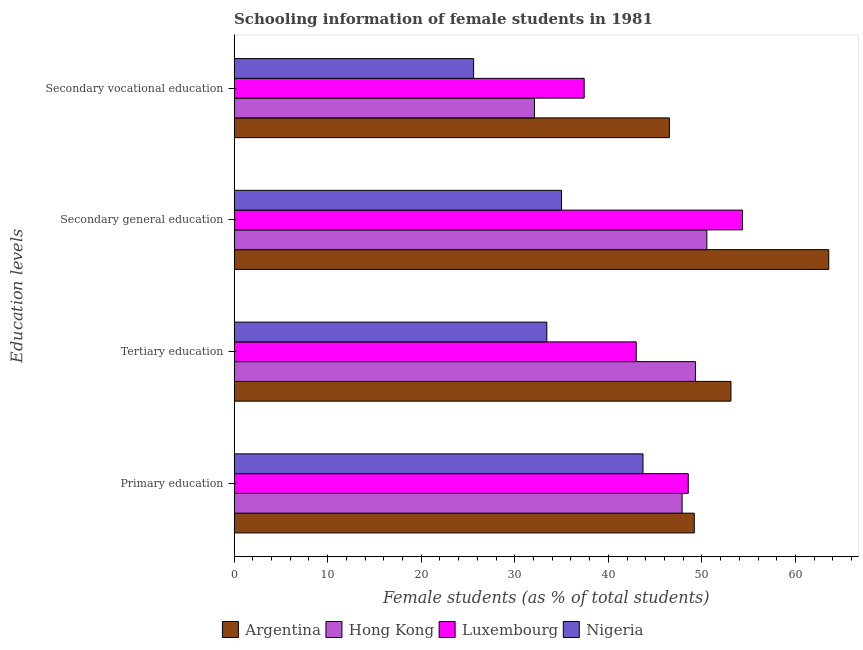How many different coloured bars are there?
Your answer should be very brief. 4. How many groups of bars are there?
Your answer should be very brief. 4. Are the number of bars per tick equal to the number of legend labels?
Make the answer very short. Yes. How many bars are there on the 4th tick from the top?
Provide a succinct answer. 4. How many bars are there on the 2nd tick from the bottom?
Make the answer very short. 4. What is the label of the 2nd group of bars from the top?
Keep it short and to the point. Secondary general education. What is the percentage of female students in secondary education in Argentina?
Your response must be concise. 63.55. Across all countries, what is the maximum percentage of female students in primary education?
Provide a succinct answer. 49.18. Across all countries, what is the minimum percentage of female students in tertiary education?
Ensure brevity in your answer.  33.42. In which country was the percentage of female students in secondary vocational education maximum?
Provide a succinct answer. Argentina. In which country was the percentage of female students in secondary vocational education minimum?
Give a very brief answer. Nigeria. What is the total percentage of female students in secondary vocational education in the graph?
Your answer should be compact. 141.63. What is the difference between the percentage of female students in tertiary education in Argentina and that in Nigeria?
Provide a short and direct response. 19.68. What is the difference between the percentage of female students in secondary vocational education in Hong Kong and the percentage of female students in secondary education in Nigeria?
Offer a very short reply. -2.89. What is the average percentage of female students in tertiary education per country?
Offer a very short reply. 44.7. What is the difference between the percentage of female students in primary education and percentage of female students in secondary education in Hong Kong?
Your answer should be compact. -2.64. In how many countries, is the percentage of female students in secondary education greater than 50 %?
Offer a very short reply. 3. What is the ratio of the percentage of female students in secondary education in Nigeria to that in Luxembourg?
Give a very brief answer. 0.64. Is the difference between the percentage of female students in primary education in Hong Kong and Argentina greater than the difference between the percentage of female students in secondary education in Hong Kong and Argentina?
Your answer should be compact. Yes. What is the difference between the highest and the second highest percentage of female students in secondary education?
Give a very brief answer. 9.22. What is the difference between the highest and the lowest percentage of female students in tertiary education?
Your answer should be very brief. 19.68. In how many countries, is the percentage of female students in tertiary education greater than the average percentage of female students in tertiary education taken over all countries?
Your answer should be compact. 2. Is the sum of the percentage of female students in primary education in Hong Kong and Nigeria greater than the maximum percentage of female students in tertiary education across all countries?
Keep it short and to the point. Yes. Is it the case that in every country, the sum of the percentage of female students in primary education and percentage of female students in secondary vocational education is greater than the sum of percentage of female students in secondary education and percentage of female students in tertiary education?
Offer a very short reply. No. What does the 2nd bar from the top in Tertiary education represents?
Ensure brevity in your answer.  Luxembourg. What does the 3rd bar from the bottom in Secondary vocational education represents?
Ensure brevity in your answer.  Luxembourg. Is it the case that in every country, the sum of the percentage of female students in primary education and percentage of female students in tertiary education is greater than the percentage of female students in secondary education?
Ensure brevity in your answer.  Yes. Are all the bars in the graph horizontal?
Offer a terse response. Yes. What is the difference between two consecutive major ticks on the X-axis?
Offer a very short reply. 10. Are the values on the major ticks of X-axis written in scientific E-notation?
Provide a short and direct response. No. Does the graph contain grids?
Your response must be concise. No. How are the legend labels stacked?
Provide a succinct answer. Horizontal. What is the title of the graph?
Offer a terse response. Schooling information of female students in 1981. Does "Puerto Rico" appear as one of the legend labels in the graph?
Your response must be concise. No. What is the label or title of the X-axis?
Your response must be concise. Female students (as % of total students). What is the label or title of the Y-axis?
Your answer should be compact. Education levels. What is the Female students (as % of total students) of Argentina in Primary education?
Make the answer very short. 49.18. What is the Female students (as % of total students) of Hong Kong in Primary education?
Provide a succinct answer. 47.88. What is the Female students (as % of total students) of Luxembourg in Primary education?
Your answer should be very brief. 48.54. What is the Female students (as % of total students) in Nigeria in Primary education?
Your answer should be compact. 43.7. What is the Female students (as % of total students) in Argentina in Tertiary education?
Make the answer very short. 53.1. What is the Female students (as % of total students) in Hong Kong in Tertiary education?
Keep it short and to the point. 49.31. What is the Female students (as % of total students) of Luxembourg in Tertiary education?
Your answer should be compact. 42.98. What is the Female students (as % of total students) in Nigeria in Tertiary education?
Your answer should be compact. 33.42. What is the Female students (as % of total students) of Argentina in Secondary general education?
Keep it short and to the point. 63.55. What is the Female students (as % of total students) of Hong Kong in Secondary general education?
Offer a very short reply. 50.53. What is the Female students (as % of total students) in Luxembourg in Secondary general education?
Keep it short and to the point. 54.33. What is the Female students (as % of total students) of Nigeria in Secondary general education?
Give a very brief answer. 34.99. What is the Female students (as % of total students) in Argentina in Secondary vocational education?
Make the answer very short. 46.52. What is the Female students (as % of total students) of Hong Kong in Secondary vocational education?
Your answer should be compact. 32.1. What is the Female students (as % of total students) of Luxembourg in Secondary vocational education?
Provide a short and direct response. 37.41. What is the Female students (as % of total students) in Nigeria in Secondary vocational education?
Give a very brief answer. 25.59. Across all Education levels, what is the maximum Female students (as % of total students) in Argentina?
Your answer should be very brief. 63.55. Across all Education levels, what is the maximum Female students (as % of total students) in Hong Kong?
Ensure brevity in your answer.  50.53. Across all Education levels, what is the maximum Female students (as % of total students) in Luxembourg?
Make the answer very short. 54.33. Across all Education levels, what is the maximum Female students (as % of total students) of Nigeria?
Make the answer very short. 43.7. Across all Education levels, what is the minimum Female students (as % of total students) in Argentina?
Keep it short and to the point. 46.52. Across all Education levels, what is the minimum Female students (as % of total students) of Hong Kong?
Make the answer very short. 32.1. Across all Education levels, what is the minimum Female students (as % of total students) of Luxembourg?
Your answer should be compact. 37.41. Across all Education levels, what is the minimum Female students (as % of total students) in Nigeria?
Give a very brief answer. 25.59. What is the total Female students (as % of total students) of Argentina in the graph?
Offer a terse response. 212.36. What is the total Female students (as % of total students) of Hong Kong in the graph?
Keep it short and to the point. 179.82. What is the total Female students (as % of total students) of Luxembourg in the graph?
Offer a very short reply. 183.26. What is the total Female students (as % of total students) in Nigeria in the graph?
Your answer should be compact. 137.71. What is the difference between the Female students (as % of total students) of Argentina in Primary education and that in Tertiary education?
Provide a short and direct response. -3.92. What is the difference between the Female students (as % of total students) of Hong Kong in Primary education and that in Tertiary education?
Your answer should be compact. -1.43. What is the difference between the Female students (as % of total students) in Luxembourg in Primary education and that in Tertiary education?
Your answer should be very brief. 5.56. What is the difference between the Female students (as % of total students) in Nigeria in Primary education and that in Tertiary education?
Offer a very short reply. 10.28. What is the difference between the Female students (as % of total students) in Argentina in Primary education and that in Secondary general education?
Offer a terse response. -14.37. What is the difference between the Female students (as % of total students) in Hong Kong in Primary education and that in Secondary general education?
Your answer should be very brief. -2.64. What is the difference between the Female students (as % of total students) in Luxembourg in Primary education and that in Secondary general education?
Offer a very short reply. -5.79. What is the difference between the Female students (as % of total students) in Nigeria in Primary education and that in Secondary general education?
Ensure brevity in your answer.  8.71. What is the difference between the Female students (as % of total students) in Argentina in Primary education and that in Secondary vocational education?
Provide a short and direct response. 2.66. What is the difference between the Female students (as % of total students) of Hong Kong in Primary education and that in Secondary vocational education?
Ensure brevity in your answer.  15.78. What is the difference between the Female students (as % of total students) of Luxembourg in Primary education and that in Secondary vocational education?
Provide a short and direct response. 11.12. What is the difference between the Female students (as % of total students) of Nigeria in Primary education and that in Secondary vocational education?
Offer a very short reply. 18.11. What is the difference between the Female students (as % of total students) in Argentina in Tertiary education and that in Secondary general education?
Give a very brief answer. -10.45. What is the difference between the Female students (as % of total students) in Hong Kong in Tertiary education and that in Secondary general education?
Provide a short and direct response. -1.22. What is the difference between the Female students (as % of total students) of Luxembourg in Tertiary education and that in Secondary general education?
Provide a short and direct response. -11.36. What is the difference between the Female students (as % of total students) of Nigeria in Tertiary education and that in Secondary general education?
Your answer should be very brief. -1.57. What is the difference between the Female students (as % of total students) in Argentina in Tertiary education and that in Secondary vocational education?
Keep it short and to the point. 6.58. What is the difference between the Female students (as % of total students) in Hong Kong in Tertiary education and that in Secondary vocational education?
Your answer should be compact. 17.2. What is the difference between the Female students (as % of total students) in Luxembourg in Tertiary education and that in Secondary vocational education?
Offer a very short reply. 5.56. What is the difference between the Female students (as % of total students) of Nigeria in Tertiary education and that in Secondary vocational education?
Your response must be concise. 7.83. What is the difference between the Female students (as % of total students) in Argentina in Secondary general education and that in Secondary vocational education?
Provide a succinct answer. 17.04. What is the difference between the Female students (as % of total students) of Hong Kong in Secondary general education and that in Secondary vocational education?
Keep it short and to the point. 18.42. What is the difference between the Female students (as % of total students) of Luxembourg in Secondary general education and that in Secondary vocational education?
Your response must be concise. 16.92. What is the difference between the Female students (as % of total students) of Nigeria in Secondary general education and that in Secondary vocational education?
Provide a succinct answer. 9.4. What is the difference between the Female students (as % of total students) of Argentina in Primary education and the Female students (as % of total students) of Hong Kong in Tertiary education?
Provide a short and direct response. -0.13. What is the difference between the Female students (as % of total students) in Argentina in Primary education and the Female students (as % of total students) in Luxembourg in Tertiary education?
Keep it short and to the point. 6.2. What is the difference between the Female students (as % of total students) in Argentina in Primary education and the Female students (as % of total students) in Nigeria in Tertiary education?
Provide a succinct answer. 15.76. What is the difference between the Female students (as % of total students) of Hong Kong in Primary education and the Female students (as % of total students) of Luxembourg in Tertiary education?
Your answer should be compact. 4.9. What is the difference between the Female students (as % of total students) of Hong Kong in Primary education and the Female students (as % of total students) of Nigeria in Tertiary education?
Offer a terse response. 14.46. What is the difference between the Female students (as % of total students) in Luxembourg in Primary education and the Female students (as % of total students) in Nigeria in Tertiary education?
Your answer should be compact. 15.11. What is the difference between the Female students (as % of total students) in Argentina in Primary education and the Female students (as % of total students) in Hong Kong in Secondary general education?
Provide a succinct answer. -1.34. What is the difference between the Female students (as % of total students) of Argentina in Primary education and the Female students (as % of total students) of Luxembourg in Secondary general education?
Offer a very short reply. -5.15. What is the difference between the Female students (as % of total students) of Argentina in Primary education and the Female students (as % of total students) of Nigeria in Secondary general education?
Provide a succinct answer. 14.19. What is the difference between the Female students (as % of total students) in Hong Kong in Primary education and the Female students (as % of total students) in Luxembourg in Secondary general education?
Provide a short and direct response. -6.45. What is the difference between the Female students (as % of total students) of Hong Kong in Primary education and the Female students (as % of total students) of Nigeria in Secondary general education?
Give a very brief answer. 12.89. What is the difference between the Female students (as % of total students) of Luxembourg in Primary education and the Female students (as % of total students) of Nigeria in Secondary general education?
Provide a short and direct response. 13.55. What is the difference between the Female students (as % of total students) in Argentina in Primary education and the Female students (as % of total students) in Hong Kong in Secondary vocational education?
Offer a very short reply. 17.08. What is the difference between the Female students (as % of total students) in Argentina in Primary education and the Female students (as % of total students) in Luxembourg in Secondary vocational education?
Your answer should be compact. 11.77. What is the difference between the Female students (as % of total students) of Argentina in Primary education and the Female students (as % of total students) of Nigeria in Secondary vocational education?
Your answer should be very brief. 23.59. What is the difference between the Female students (as % of total students) of Hong Kong in Primary education and the Female students (as % of total students) of Luxembourg in Secondary vocational education?
Provide a succinct answer. 10.47. What is the difference between the Female students (as % of total students) of Hong Kong in Primary education and the Female students (as % of total students) of Nigeria in Secondary vocational education?
Keep it short and to the point. 22.29. What is the difference between the Female students (as % of total students) of Luxembourg in Primary education and the Female students (as % of total students) of Nigeria in Secondary vocational education?
Your response must be concise. 22.94. What is the difference between the Female students (as % of total students) in Argentina in Tertiary education and the Female students (as % of total students) in Hong Kong in Secondary general education?
Give a very brief answer. 2.58. What is the difference between the Female students (as % of total students) of Argentina in Tertiary education and the Female students (as % of total students) of Luxembourg in Secondary general education?
Your answer should be compact. -1.23. What is the difference between the Female students (as % of total students) in Argentina in Tertiary education and the Female students (as % of total students) in Nigeria in Secondary general education?
Keep it short and to the point. 18.11. What is the difference between the Female students (as % of total students) of Hong Kong in Tertiary education and the Female students (as % of total students) of Luxembourg in Secondary general education?
Keep it short and to the point. -5.03. What is the difference between the Female students (as % of total students) in Hong Kong in Tertiary education and the Female students (as % of total students) in Nigeria in Secondary general education?
Ensure brevity in your answer.  14.31. What is the difference between the Female students (as % of total students) of Luxembourg in Tertiary education and the Female students (as % of total students) of Nigeria in Secondary general education?
Your answer should be very brief. 7.98. What is the difference between the Female students (as % of total students) of Argentina in Tertiary education and the Female students (as % of total students) of Hong Kong in Secondary vocational education?
Provide a short and direct response. 21. What is the difference between the Female students (as % of total students) of Argentina in Tertiary education and the Female students (as % of total students) of Luxembourg in Secondary vocational education?
Provide a short and direct response. 15.69. What is the difference between the Female students (as % of total students) of Argentina in Tertiary education and the Female students (as % of total students) of Nigeria in Secondary vocational education?
Provide a succinct answer. 27.51. What is the difference between the Female students (as % of total students) in Hong Kong in Tertiary education and the Female students (as % of total students) in Luxembourg in Secondary vocational education?
Your response must be concise. 11.89. What is the difference between the Female students (as % of total students) in Hong Kong in Tertiary education and the Female students (as % of total students) in Nigeria in Secondary vocational education?
Your response must be concise. 23.71. What is the difference between the Female students (as % of total students) of Luxembourg in Tertiary education and the Female students (as % of total students) of Nigeria in Secondary vocational education?
Make the answer very short. 17.38. What is the difference between the Female students (as % of total students) in Argentina in Secondary general education and the Female students (as % of total students) in Hong Kong in Secondary vocational education?
Provide a succinct answer. 31.45. What is the difference between the Female students (as % of total students) in Argentina in Secondary general education and the Female students (as % of total students) in Luxembourg in Secondary vocational education?
Offer a very short reply. 26.14. What is the difference between the Female students (as % of total students) of Argentina in Secondary general education and the Female students (as % of total students) of Nigeria in Secondary vocational education?
Your response must be concise. 37.96. What is the difference between the Female students (as % of total students) of Hong Kong in Secondary general education and the Female students (as % of total students) of Luxembourg in Secondary vocational education?
Give a very brief answer. 13.11. What is the difference between the Female students (as % of total students) of Hong Kong in Secondary general education and the Female students (as % of total students) of Nigeria in Secondary vocational education?
Make the answer very short. 24.93. What is the difference between the Female students (as % of total students) of Luxembourg in Secondary general education and the Female students (as % of total students) of Nigeria in Secondary vocational education?
Give a very brief answer. 28.74. What is the average Female students (as % of total students) of Argentina per Education levels?
Offer a very short reply. 53.09. What is the average Female students (as % of total students) of Hong Kong per Education levels?
Your answer should be compact. 44.95. What is the average Female students (as % of total students) of Luxembourg per Education levels?
Your answer should be compact. 45.82. What is the average Female students (as % of total students) of Nigeria per Education levels?
Make the answer very short. 34.43. What is the difference between the Female students (as % of total students) of Argentina and Female students (as % of total students) of Hong Kong in Primary education?
Your answer should be very brief. 1.3. What is the difference between the Female students (as % of total students) in Argentina and Female students (as % of total students) in Luxembourg in Primary education?
Your answer should be very brief. 0.64. What is the difference between the Female students (as % of total students) in Argentina and Female students (as % of total students) in Nigeria in Primary education?
Offer a very short reply. 5.48. What is the difference between the Female students (as % of total students) of Hong Kong and Female students (as % of total students) of Luxembourg in Primary education?
Ensure brevity in your answer.  -0.66. What is the difference between the Female students (as % of total students) in Hong Kong and Female students (as % of total students) in Nigeria in Primary education?
Give a very brief answer. 4.18. What is the difference between the Female students (as % of total students) of Luxembourg and Female students (as % of total students) of Nigeria in Primary education?
Your response must be concise. 4.84. What is the difference between the Female students (as % of total students) of Argentina and Female students (as % of total students) of Hong Kong in Tertiary education?
Your answer should be compact. 3.8. What is the difference between the Female students (as % of total students) in Argentina and Female students (as % of total students) in Luxembourg in Tertiary education?
Keep it short and to the point. 10.13. What is the difference between the Female students (as % of total students) of Argentina and Female students (as % of total students) of Nigeria in Tertiary education?
Your answer should be very brief. 19.68. What is the difference between the Female students (as % of total students) in Hong Kong and Female students (as % of total students) in Luxembourg in Tertiary education?
Your response must be concise. 6.33. What is the difference between the Female students (as % of total students) in Hong Kong and Female students (as % of total students) in Nigeria in Tertiary education?
Offer a terse response. 15.88. What is the difference between the Female students (as % of total students) in Luxembourg and Female students (as % of total students) in Nigeria in Tertiary education?
Your answer should be very brief. 9.55. What is the difference between the Female students (as % of total students) in Argentina and Female students (as % of total students) in Hong Kong in Secondary general education?
Ensure brevity in your answer.  13.03. What is the difference between the Female students (as % of total students) in Argentina and Female students (as % of total students) in Luxembourg in Secondary general education?
Your response must be concise. 9.22. What is the difference between the Female students (as % of total students) in Argentina and Female students (as % of total students) in Nigeria in Secondary general education?
Your answer should be compact. 28.56. What is the difference between the Female students (as % of total students) in Hong Kong and Female students (as % of total students) in Luxembourg in Secondary general education?
Ensure brevity in your answer.  -3.81. What is the difference between the Female students (as % of total students) in Hong Kong and Female students (as % of total students) in Nigeria in Secondary general education?
Offer a terse response. 15.53. What is the difference between the Female students (as % of total students) in Luxembourg and Female students (as % of total students) in Nigeria in Secondary general education?
Ensure brevity in your answer.  19.34. What is the difference between the Female students (as % of total students) in Argentina and Female students (as % of total students) in Hong Kong in Secondary vocational education?
Keep it short and to the point. 14.42. What is the difference between the Female students (as % of total students) in Argentina and Female students (as % of total students) in Luxembourg in Secondary vocational education?
Ensure brevity in your answer.  9.1. What is the difference between the Female students (as % of total students) of Argentina and Female students (as % of total students) of Nigeria in Secondary vocational education?
Your answer should be compact. 20.92. What is the difference between the Female students (as % of total students) of Hong Kong and Female students (as % of total students) of Luxembourg in Secondary vocational education?
Provide a short and direct response. -5.31. What is the difference between the Female students (as % of total students) in Hong Kong and Female students (as % of total students) in Nigeria in Secondary vocational education?
Provide a short and direct response. 6.51. What is the difference between the Female students (as % of total students) of Luxembourg and Female students (as % of total students) of Nigeria in Secondary vocational education?
Your answer should be compact. 11.82. What is the ratio of the Female students (as % of total students) of Argentina in Primary education to that in Tertiary education?
Give a very brief answer. 0.93. What is the ratio of the Female students (as % of total students) in Hong Kong in Primary education to that in Tertiary education?
Provide a short and direct response. 0.97. What is the ratio of the Female students (as % of total students) of Luxembourg in Primary education to that in Tertiary education?
Provide a succinct answer. 1.13. What is the ratio of the Female students (as % of total students) of Nigeria in Primary education to that in Tertiary education?
Keep it short and to the point. 1.31. What is the ratio of the Female students (as % of total students) in Argentina in Primary education to that in Secondary general education?
Your answer should be compact. 0.77. What is the ratio of the Female students (as % of total students) of Hong Kong in Primary education to that in Secondary general education?
Your response must be concise. 0.95. What is the ratio of the Female students (as % of total students) in Luxembourg in Primary education to that in Secondary general education?
Give a very brief answer. 0.89. What is the ratio of the Female students (as % of total students) of Nigeria in Primary education to that in Secondary general education?
Ensure brevity in your answer.  1.25. What is the ratio of the Female students (as % of total students) in Argentina in Primary education to that in Secondary vocational education?
Ensure brevity in your answer.  1.06. What is the ratio of the Female students (as % of total students) in Hong Kong in Primary education to that in Secondary vocational education?
Give a very brief answer. 1.49. What is the ratio of the Female students (as % of total students) of Luxembourg in Primary education to that in Secondary vocational education?
Offer a terse response. 1.3. What is the ratio of the Female students (as % of total students) in Nigeria in Primary education to that in Secondary vocational education?
Make the answer very short. 1.71. What is the ratio of the Female students (as % of total students) in Argentina in Tertiary education to that in Secondary general education?
Ensure brevity in your answer.  0.84. What is the ratio of the Female students (as % of total students) of Hong Kong in Tertiary education to that in Secondary general education?
Offer a terse response. 0.98. What is the ratio of the Female students (as % of total students) of Luxembourg in Tertiary education to that in Secondary general education?
Your answer should be compact. 0.79. What is the ratio of the Female students (as % of total students) in Nigeria in Tertiary education to that in Secondary general education?
Your answer should be compact. 0.96. What is the ratio of the Female students (as % of total students) of Argentina in Tertiary education to that in Secondary vocational education?
Give a very brief answer. 1.14. What is the ratio of the Female students (as % of total students) in Hong Kong in Tertiary education to that in Secondary vocational education?
Your answer should be compact. 1.54. What is the ratio of the Female students (as % of total students) in Luxembourg in Tertiary education to that in Secondary vocational education?
Your answer should be compact. 1.15. What is the ratio of the Female students (as % of total students) in Nigeria in Tertiary education to that in Secondary vocational education?
Your response must be concise. 1.31. What is the ratio of the Female students (as % of total students) of Argentina in Secondary general education to that in Secondary vocational education?
Make the answer very short. 1.37. What is the ratio of the Female students (as % of total students) in Hong Kong in Secondary general education to that in Secondary vocational education?
Offer a very short reply. 1.57. What is the ratio of the Female students (as % of total students) of Luxembourg in Secondary general education to that in Secondary vocational education?
Provide a succinct answer. 1.45. What is the ratio of the Female students (as % of total students) in Nigeria in Secondary general education to that in Secondary vocational education?
Make the answer very short. 1.37. What is the difference between the highest and the second highest Female students (as % of total students) in Argentina?
Keep it short and to the point. 10.45. What is the difference between the highest and the second highest Female students (as % of total students) in Hong Kong?
Offer a very short reply. 1.22. What is the difference between the highest and the second highest Female students (as % of total students) of Luxembourg?
Your response must be concise. 5.79. What is the difference between the highest and the second highest Female students (as % of total students) in Nigeria?
Ensure brevity in your answer.  8.71. What is the difference between the highest and the lowest Female students (as % of total students) of Argentina?
Keep it short and to the point. 17.04. What is the difference between the highest and the lowest Female students (as % of total students) of Hong Kong?
Provide a short and direct response. 18.42. What is the difference between the highest and the lowest Female students (as % of total students) in Luxembourg?
Keep it short and to the point. 16.92. What is the difference between the highest and the lowest Female students (as % of total students) in Nigeria?
Ensure brevity in your answer.  18.11. 